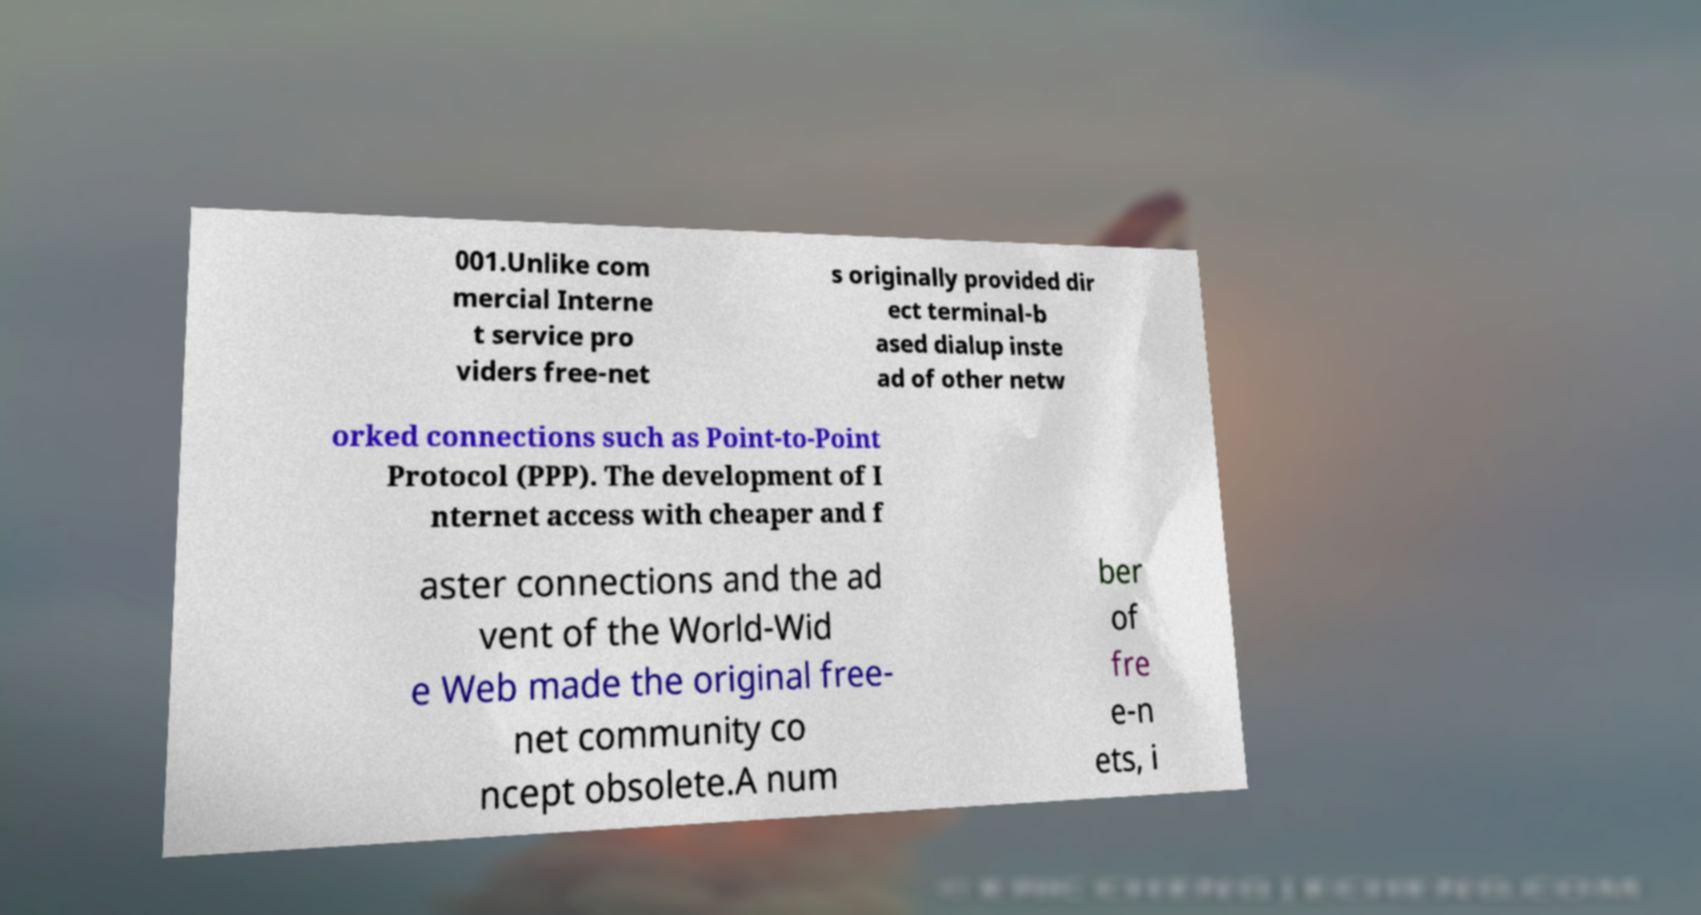I need the written content from this picture converted into text. Can you do that? 001.Unlike com mercial Interne t service pro viders free-net s originally provided dir ect terminal-b ased dialup inste ad of other netw orked connections such as Point-to-Point Protocol (PPP). The development of I nternet access with cheaper and f aster connections and the ad vent of the World-Wid e Web made the original free- net community co ncept obsolete.A num ber of fre e-n ets, i 